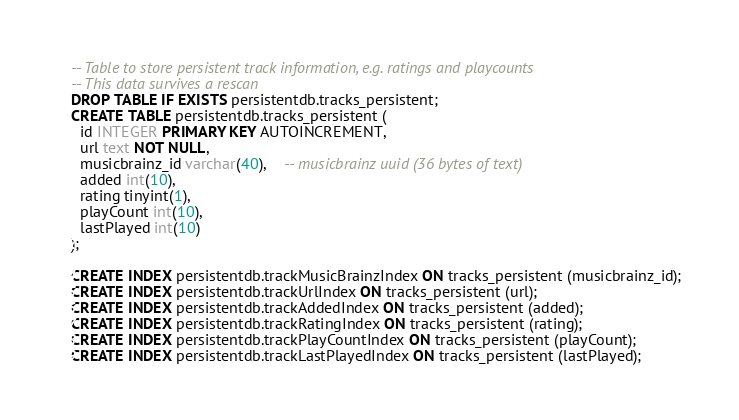Convert code to text. <code><loc_0><loc_0><loc_500><loc_500><_SQL_>-- Table to store persistent track information, e.g. ratings and playcounts
-- This data survives a rescan
DROP TABLE IF EXISTS persistentdb.tracks_persistent;
CREATE TABLE persistentdb.tracks_persistent (
  id INTEGER PRIMARY KEY AUTOINCREMENT,
  url text NOT NULL,
  musicbrainz_id varchar(40),	-- musicbrainz uuid (36 bytes of text)
  added int(10),
  rating tinyint(1),
  playCount int(10),
  lastPlayed int(10)
);

CREATE INDEX persistentdb.trackMusicBrainzIndex ON tracks_persistent (musicbrainz_id);
CREATE INDEX persistentdb.trackUrlIndex ON tracks_persistent (url);
CREATE INDEX persistentdb.trackAddedIndex ON tracks_persistent (added);
CREATE INDEX persistentdb.trackRatingIndex ON tracks_persistent (rating);
CREATE INDEX persistentdb.trackPlayCountIndex ON tracks_persistent (playCount);
CREATE INDEX persistentdb.trackLastPlayedIndex ON tracks_persistent (lastPlayed);
</code> 